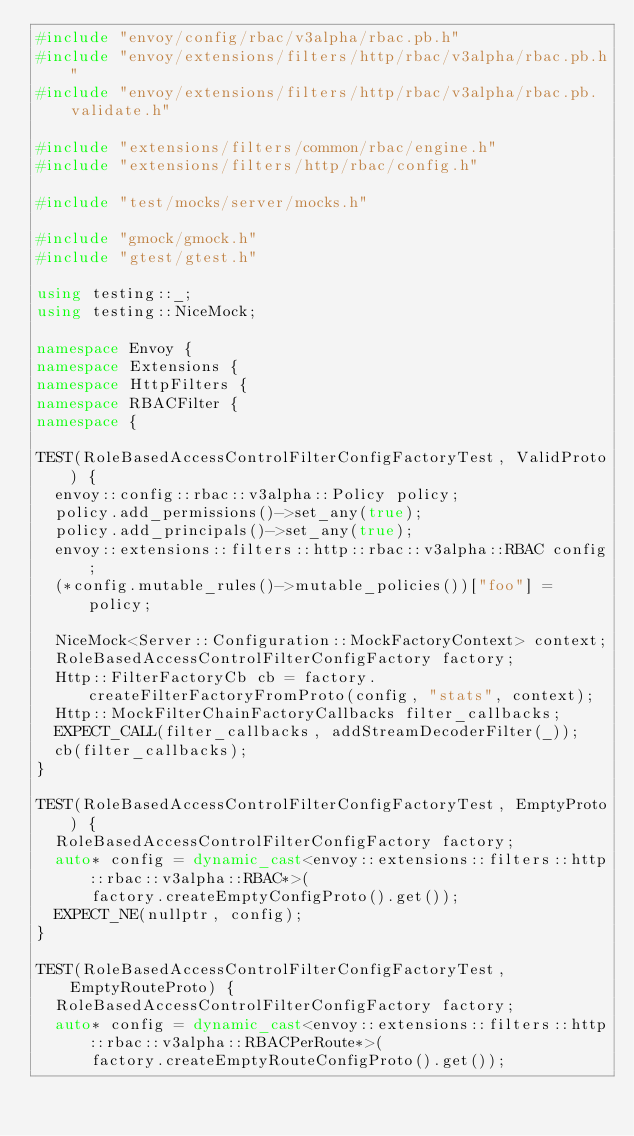Convert code to text. <code><loc_0><loc_0><loc_500><loc_500><_C++_>#include "envoy/config/rbac/v3alpha/rbac.pb.h"
#include "envoy/extensions/filters/http/rbac/v3alpha/rbac.pb.h"
#include "envoy/extensions/filters/http/rbac/v3alpha/rbac.pb.validate.h"

#include "extensions/filters/common/rbac/engine.h"
#include "extensions/filters/http/rbac/config.h"

#include "test/mocks/server/mocks.h"

#include "gmock/gmock.h"
#include "gtest/gtest.h"

using testing::_;
using testing::NiceMock;

namespace Envoy {
namespace Extensions {
namespace HttpFilters {
namespace RBACFilter {
namespace {

TEST(RoleBasedAccessControlFilterConfigFactoryTest, ValidProto) {
  envoy::config::rbac::v3alpha::Policy policy;
  policy.add_permissions()->set_any(true);
  policy.add_principals()->set_any(true);
  envoy::extensions::filters::http::rbac::v3alpha::RBAC config;
  (*config.mutable_rules()->mutable_policies())["foo"] = policy;

  NiceMock<Server::Configuration::MockFactoryContext> context;
  RoleBasedAccessControlFilterConfigFactory factory;
  Http::FilterFactoryCb cb = factory.createFilterFactoryFromProto(config, "stats", context);
  Http::MockFilterChainFactoryCallbacks filter_callbacks;
  EXPECT_CALL(filter_callbacks, addStreamDecoderFilter(_));
  cb(filter_callbacks);
}

TEST(RoleBasedAccessControlFilterConfigFactoryTest, EmptyProto) {
  RoleBasedAccessControlFilterConfigFactory factory;
  auto* config = dynamic_cast<envoy::extensions::filters::http::rbac::v3alpha::RBAC*>(
      factory.createEmptyConfigProto().get());
  EXPECT_NE(nullptr, config);
}

TEST(RoleBasedAccessControlFilterConfigFactoryTest, EmptyRouteProto) {
  RoleBasedAccessControlFilterConfigFactory factory;
  auto* config = dynamic_cast<envoy::extensions::filters::http::rbac::v3alpha::RBACPerRoute*>(
      factory.createEmptyRouteConfigProto().get());</code> 